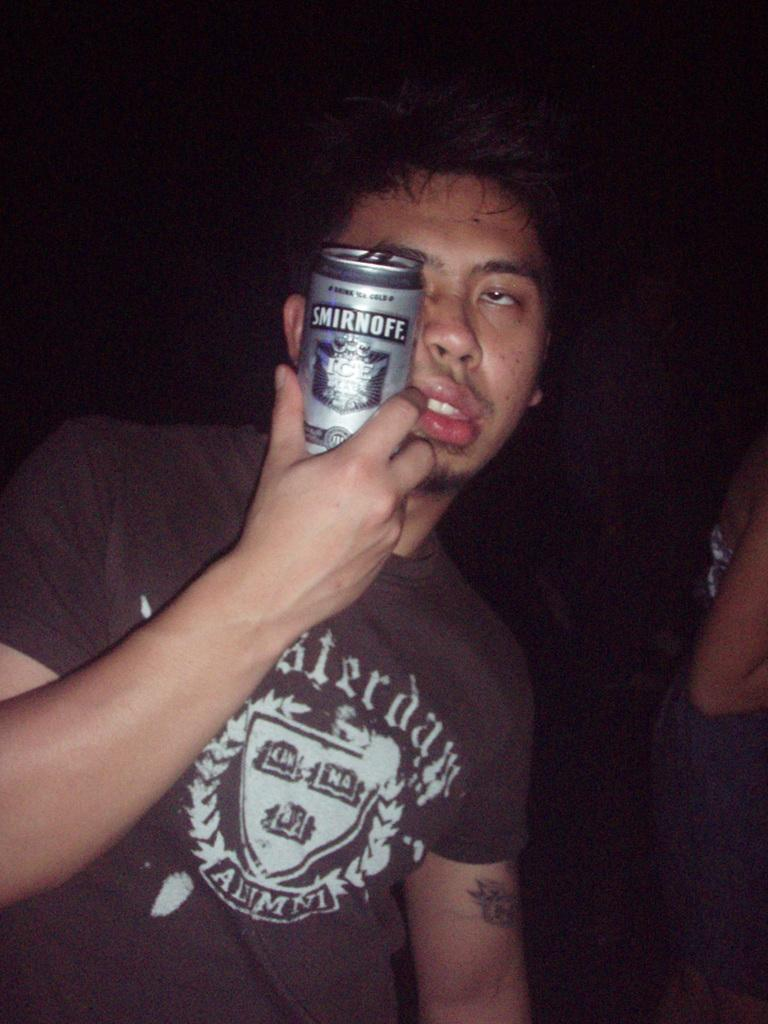Who is the main subject in the image? There is a man in the image. What is the man holding in his hand? The man is holding a tin in his hand. Are there any other people present in the image? Yes, there is at least one other person in the image. What can be observed about the background of the image? The background of the image is dark. How many children are playing in the image? There is no mention of children in the image; it only features a man holding a tin and at least one other person. 